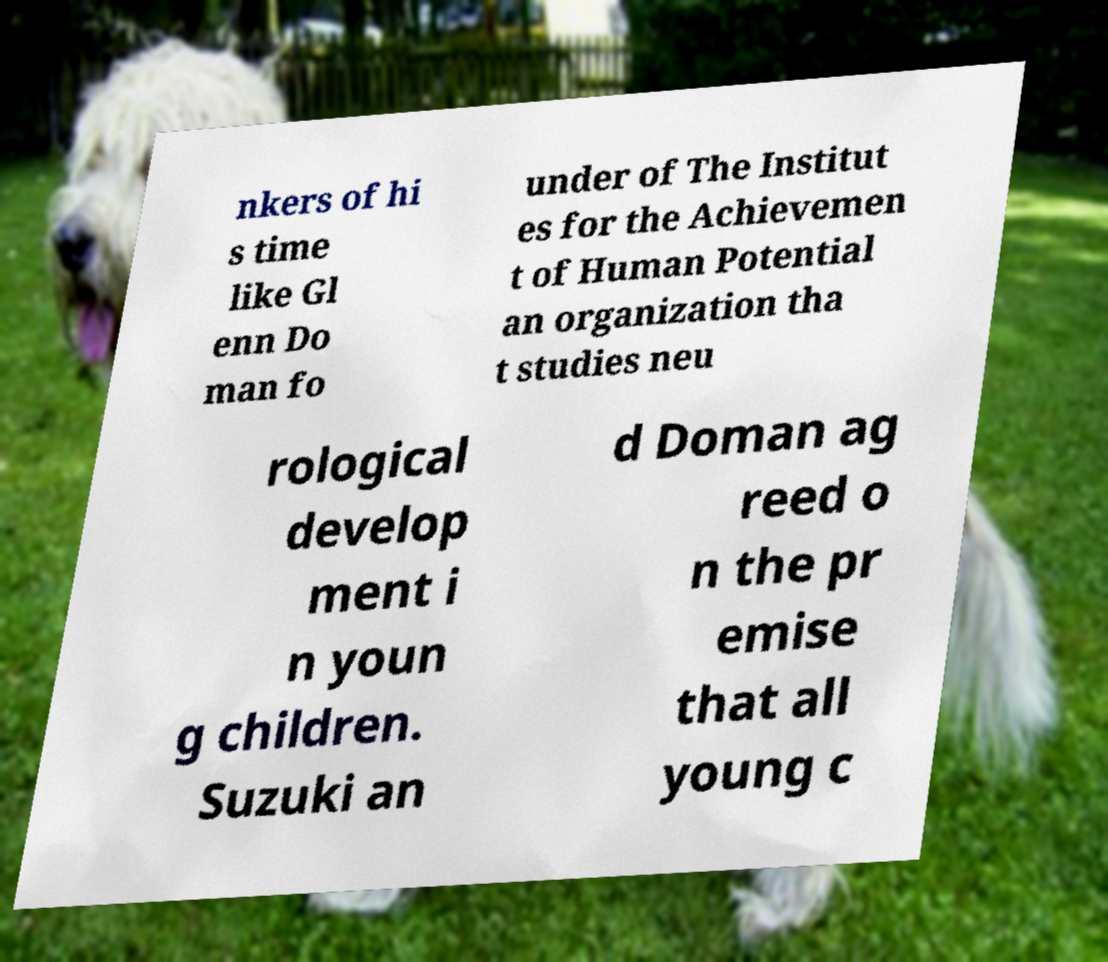Please read and relay the text visible in this image. What does it say? nkers of hi s time like Gl enn Do man fo under of The Institut es for the Achievemen t of Human Potential an organization tha t studies neu rological develop ment i n youn g children. Suzuki an d Doman ag reed o n the pr emise that all young c 